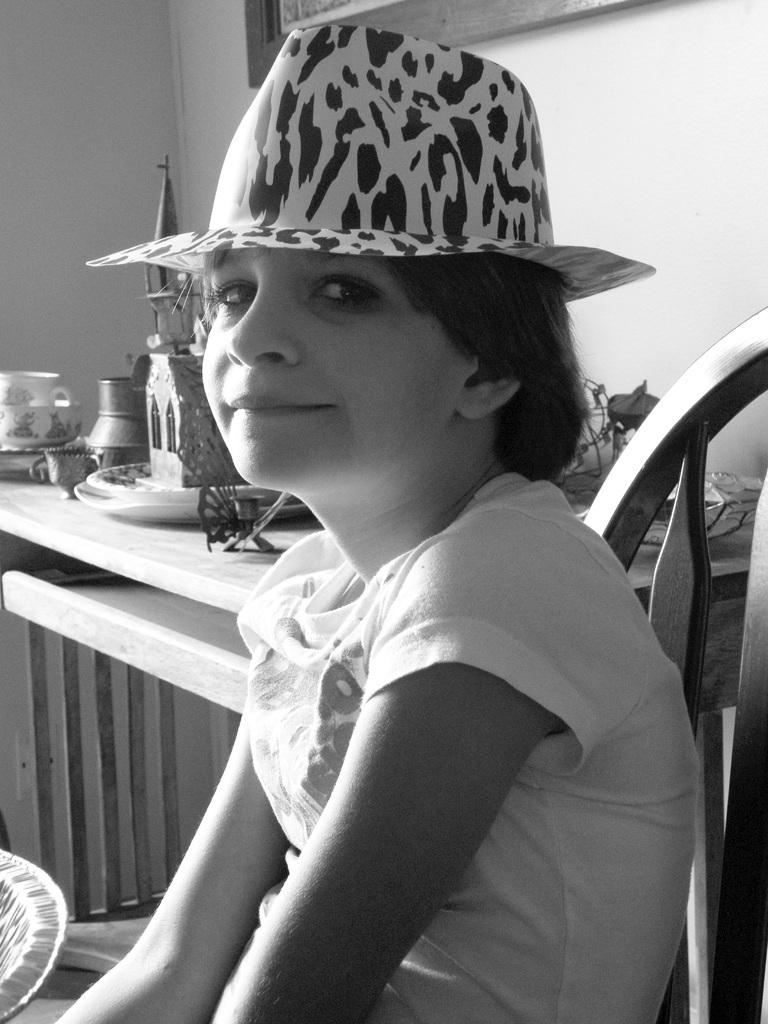What is the color scheme of the image? The image is black and white. Who is present in the image? There is a girl in the image. What is the girl doing in the image? The girl is sitting on a chair. What can be seen in the background of the image? There is a table and a frame on a wall in the background of the image. What type of protest is happening in the image? There is no protest present in the image; it features a girl sitting on a chair. Can you see any cords hanging from the ceiling in the image? There is no mention of cords in the image; it is a black and white image of a girl sitting on a chair with a table and a frame on a wall in the background. 